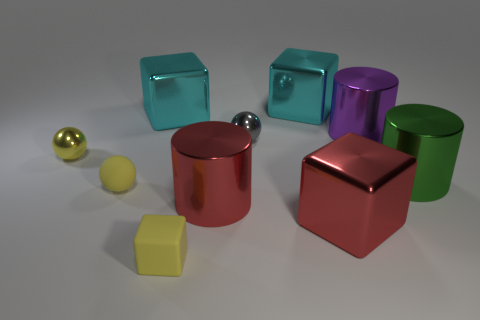What can the shadows tell us about the light source in this image? The shadows are soft-edged and fall predominantly to the right of the objects, indicating that the light source is to the left of the scene. The diffused nature of the shadows suggests the light source is not only strong but also quite broad, similar to a softbox used in photography to create a gentle and even illumination. 